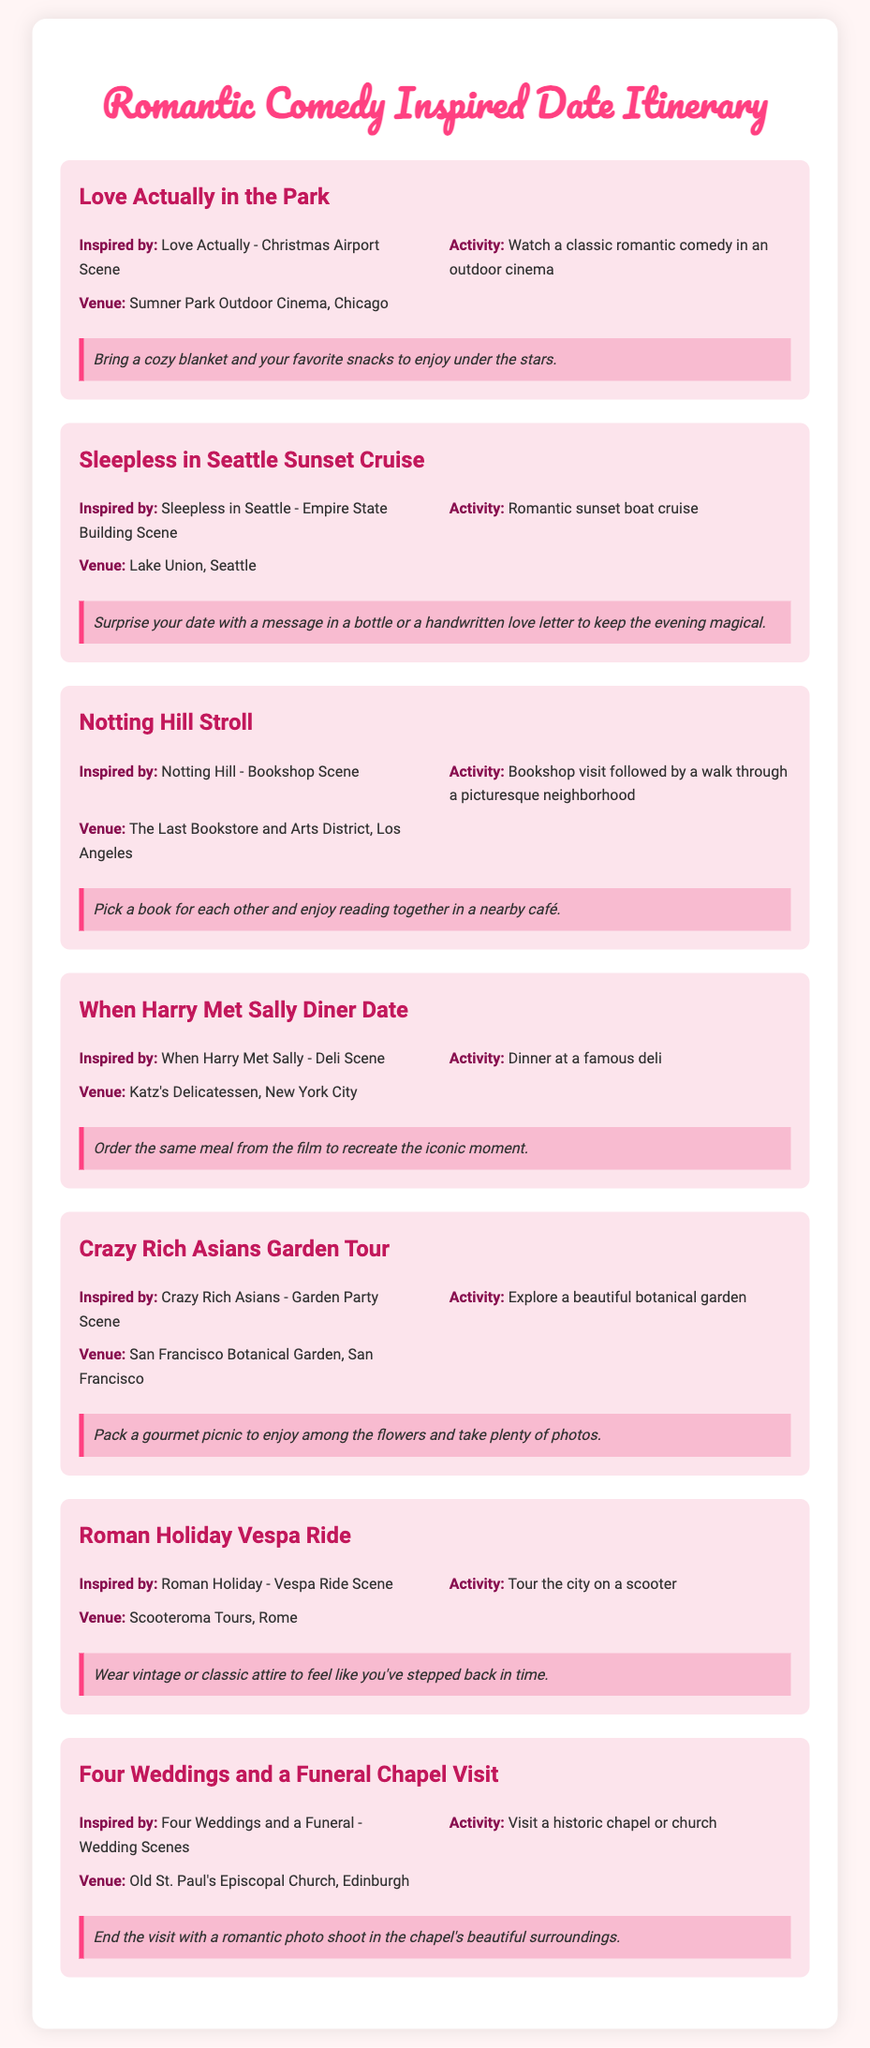What is the first date idea listed? The first date idea listed is "Love Actually in the Park."
Answer: Love Actually in the Park Which city hosts the venue for "Sleepless in Seattle Sunset Cruise"? The venue is located in Seattle.
Answer: Seattle What activity is suggested for the "Notting Hill Stroll"? The activity suggested is a bookshop visit followed by a walk.
Answer: Bookshop visit followed by a walk Which iconic film is referenced in the "When Harry Met Sally Diner Date"? The iconic film referenced is "When Harry Met Sally."
Answer: When Harry Met Sally What special tip is provided for the "Crazy Rich Asians Garden Tour"? The special tip is to pack a gourmet picnic.
Answer: Pack a gourmet picnic How many wedding scenes inspired the "Four Weddings and a Funeral Chapel Visit"? The date idea was inspired by four wedding scenes.
Answer: Four What is the venue for the "Roman Holiday Vespa Ride"? The venue is Scooteroma Tours.
Answer: Scooteroma Tours What type of attire is recommended for the "Roman Holiday Vespa Ride"? The recommended attire is vintage or classic.
Answer: Vintage or classic Which outdoor venue is suggested in the first date idea? The first date idea suggests Sumner Park Outdoor Cinema.
Answer: Sumner Park Outdoor Cinema 